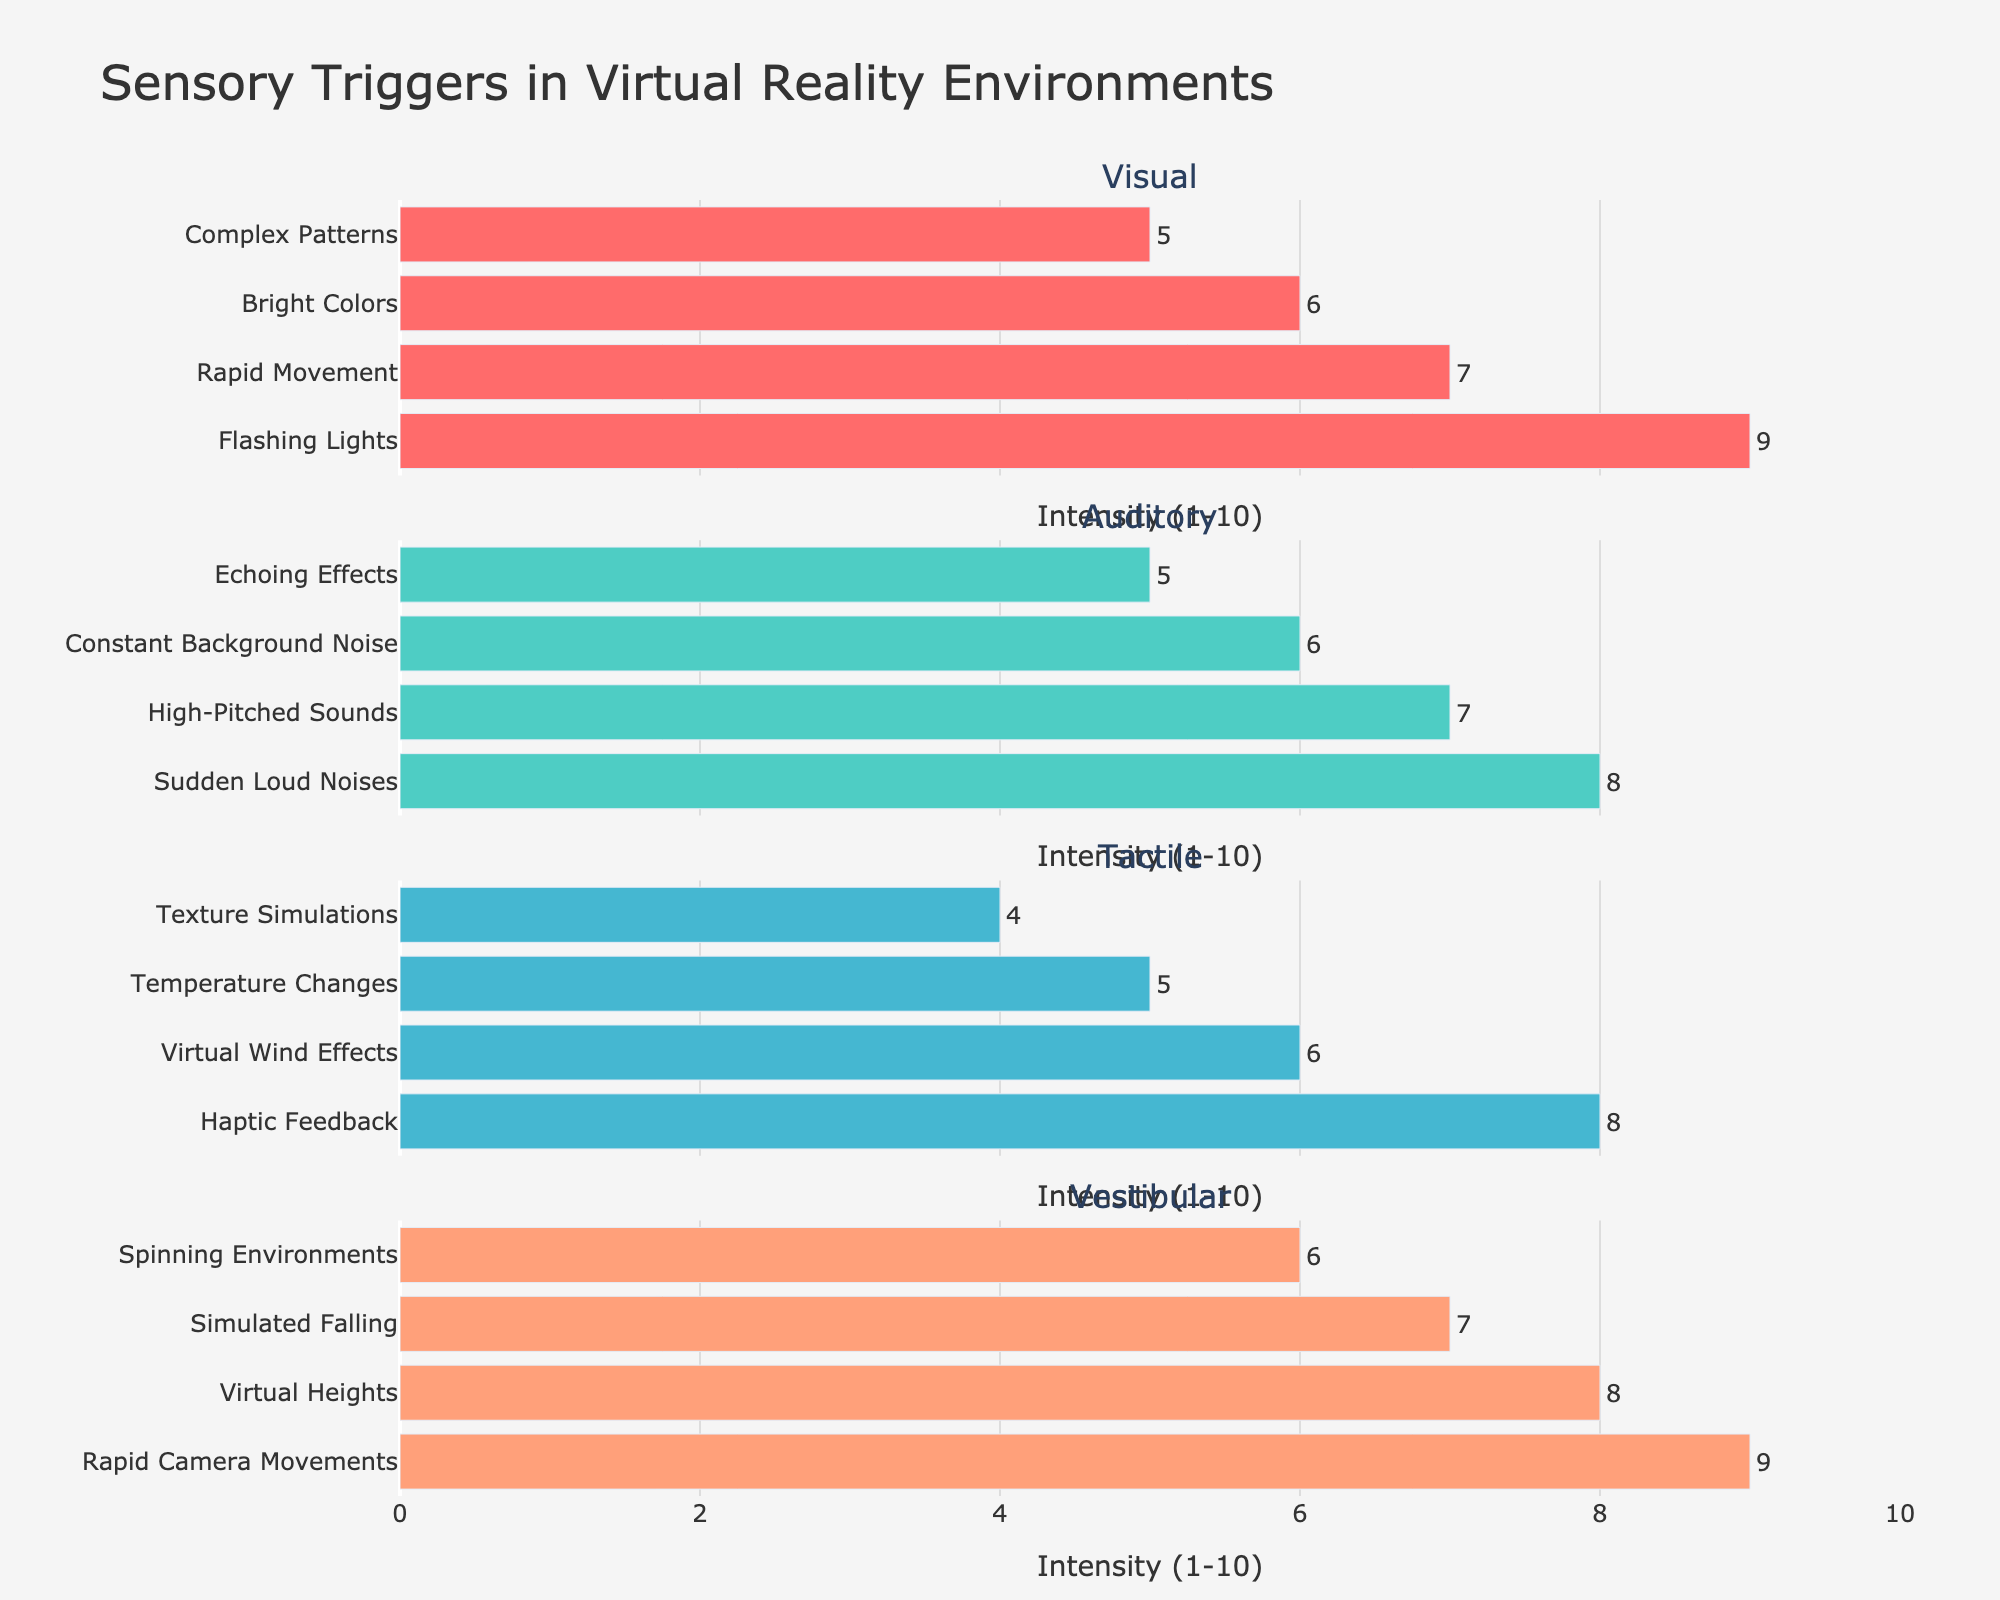What's the title of the figure? The title of the figure is at the top center of the plot. It summarizes what the entire plot is about.
Answer: Campus Social Events Attendance What is the y-axis label for the subplot titled "Biology Club"? Each subplot has a y-axis label "Attendance" to define what is being measured. This label is identical across all subplots, including the one for "Biology Club".
Answer: Attendance In which month did the Education Society have the highest attendance? To find this, look at the subplot for "Education Society" and identify the peak point.
Answer: May Which student group had the highest attendance in December? Look at the December data points across all subplots and compare. The highest value will indicate which group had the highest attendance.
Answer: Student Union What's the average attendance for the Science Alliance group over the academic year? Calculate the sum of all monthly attendance for Science Alliance and divide by the number of months (9). That is, (52 + 47 + 50 + 40 + 45 + 48 + 51 + 54 + 58) = 445, then 445 / 9 = 49.44.
Answer: 49.44 How did the attendance for the Biology Club change from September to December? Compare the attendance values for the Biology Club in September and December. September had 45, and December had 30. The change is 45 - 30 = 15 drop.
Answer: Decreased by 15 Which group showed the most consistent attendance rates from month to month? To identify this, visually assess which group's line plot is the smoothest with the smallest fluctuations month to month. This appears to be the Student Union.
Answer: Student Union Compare the February attendance of Education Society and Science Alliance. Which one was higher? Refer to the February data points in the respective subplots. Education Society had 68, and Science Alliance had 48.
Answer: Education Society What is the general trend in the attendance rates of the Biology Club throughout the year? Observe the line plot for Biology Club. It shows a decreasing trend initially with some fluctuations but generally increasing towards the end of the academic year.
Answer: Overall increasing 